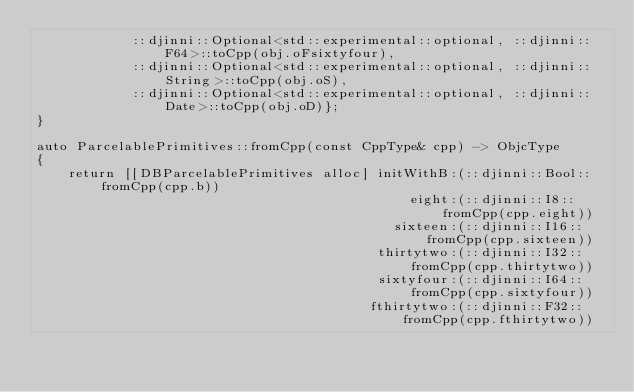<code> <loc_0><loc_0><loc_500><loc_500><_ObjectiveC_>            ::djinni::Optional<std::experimental::optional, ::djinni::F64>::toCpp(obj.oFsixtyfour),
            ::djinni::Optional<std::experimental::optional, ::djinni::String>::toCpp(obj.oS),
            ::djinni::Optional<std::experimental::optional, ::djinni::Date>::toCpp(obj.oD)};
}

auto ParcelablePrimitives::fromCpp(const CppType& cpp) -> ObjcType
{
    return [[DBParcelablePrimitives alloc] initWithB:(::djinni::Bool::fromCpp(cpp.b))
                                               eight:(::djinni::I8::fromCpp(cpp.eight))
                                             sixteen:(::djinni::I16::fromCpp(cpp.sixteen))
                                           thirtytwo:(::djinni::I32::fromCpp(cpp.thirtytwo))
                                           sixtyfour:(::djinni::I64::fromCpp(cpp.sixtyfour))
                                          fthirtytwo:(::djinni::F32::fromCpp(cpp.fthirtytwo))</code> 